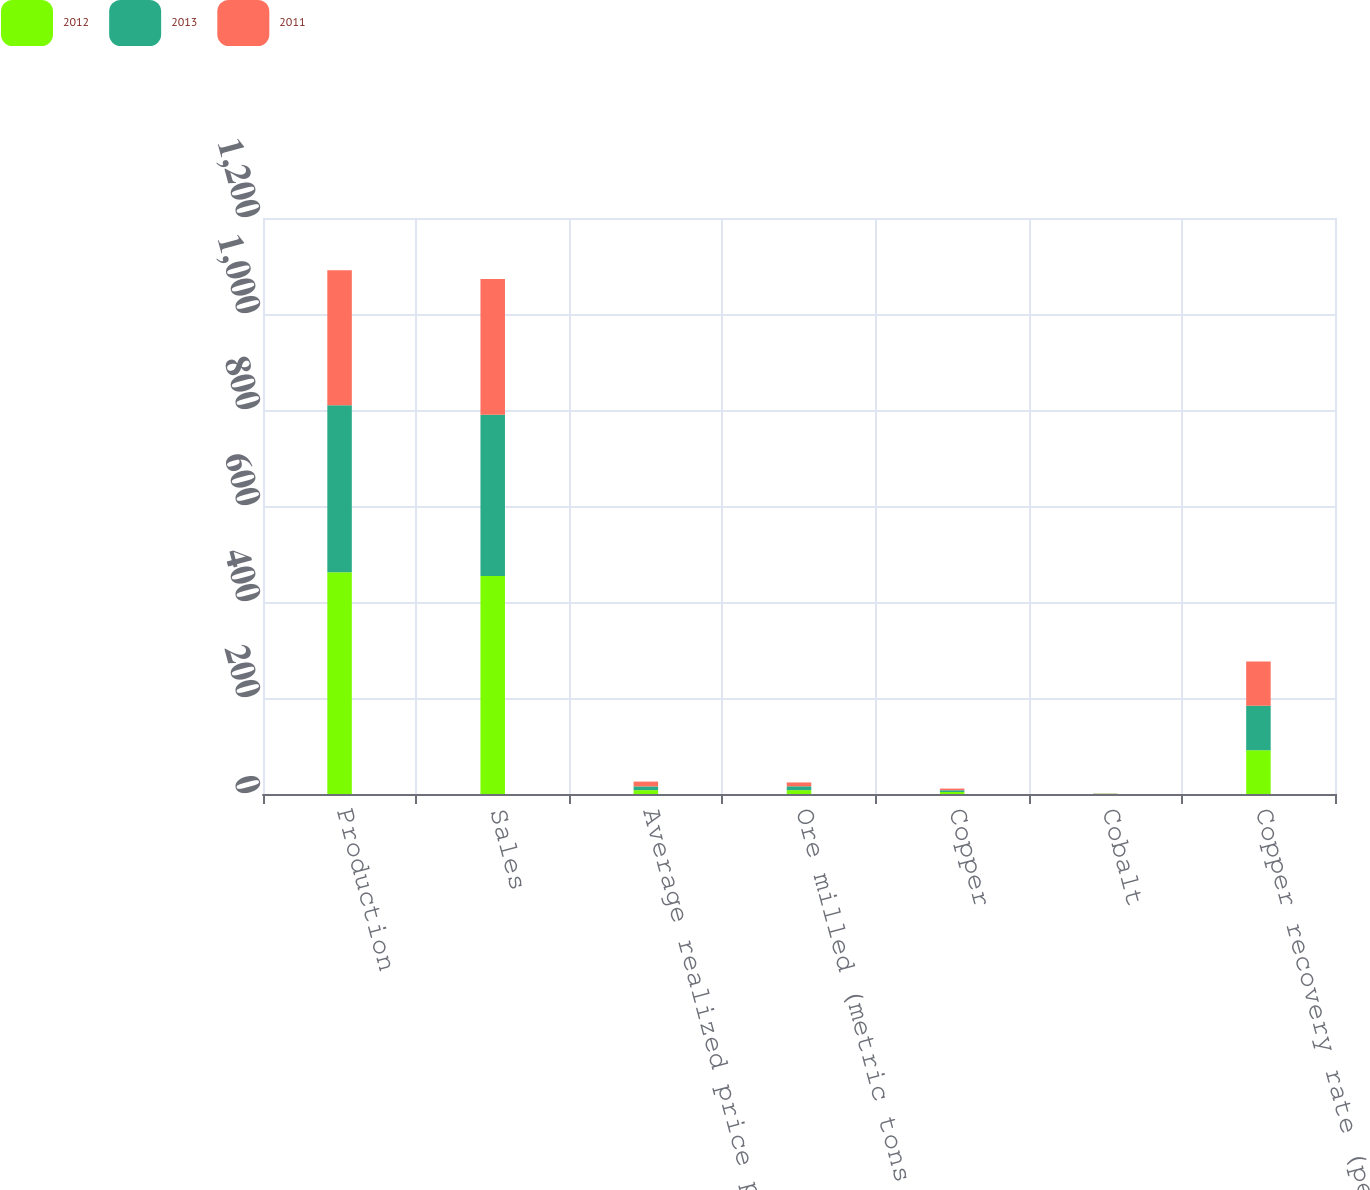Convert chart. <chart><loc_0><loc_0><loc_500><loc_500><stacked_bar_chart><ecel><fcel>Production<fcel>Sales<fcel>Average realized price per<fcel>Ore milled (metric tons per<fcel>Copper<fcel>Cobalt<fcel>Copper recovery rate (percent)<nl><fcel>2012<fcel>462<fcel>454<fcel>8.02<fcel>8.02<fcel>4.22<fcel>0.37<fcel>91.4<nl><fcel>2013<fcel>348<fcel>336<fcel>7.83<fcel>8.02<fcel>3.62<fcel>0.37<fcel>92.4<nl><fcel>2011<fcel>281<fcel>283<fcel>9.99<fcel>8.02<fcel>3.41<fcel>0.4<fcel>92.5<nl></chart> 